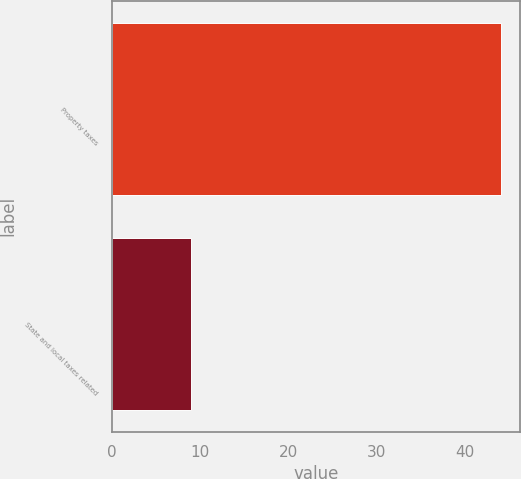<chart> <loc_0><loc_0><loc_500><loc_500><bar_chart><fcel>Property taxes<fcel>State and local taxes related<nl><fcel>44<fcel>9<nl></chart> 